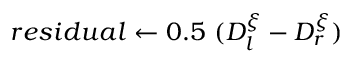Convert formula to latex. <formula><loc_0><loc_0><loc_500><loc_500>r e s i d u a l \gets 0 . 5 ( D _ { l } ^ { \xi } - D _ { r } ^ { \xi } )</formula> 